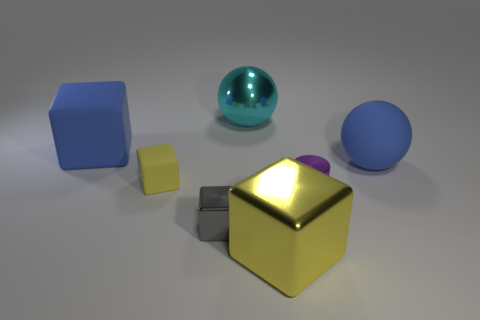Can you talk about the lighting and how it affects the mood of this scene? The lighting in this scene appears to come from above, casting soft shadows beneath each object. This overhead lighting creates a calm and even tone throughout the scene. The reflection on the golden cube and blue sphere adds depth and a hint of warmth, contributing to a serene and contemplative mood. The absence of harsh shadows or contrasting light sources gives the impression of a controlled and neutral environment, typical of a studio setup. 